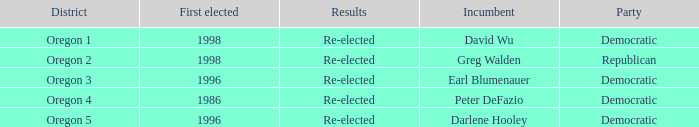Who is the incumbent for the Oregon 5 District that was elected in 1996? Darlene Hooley. 